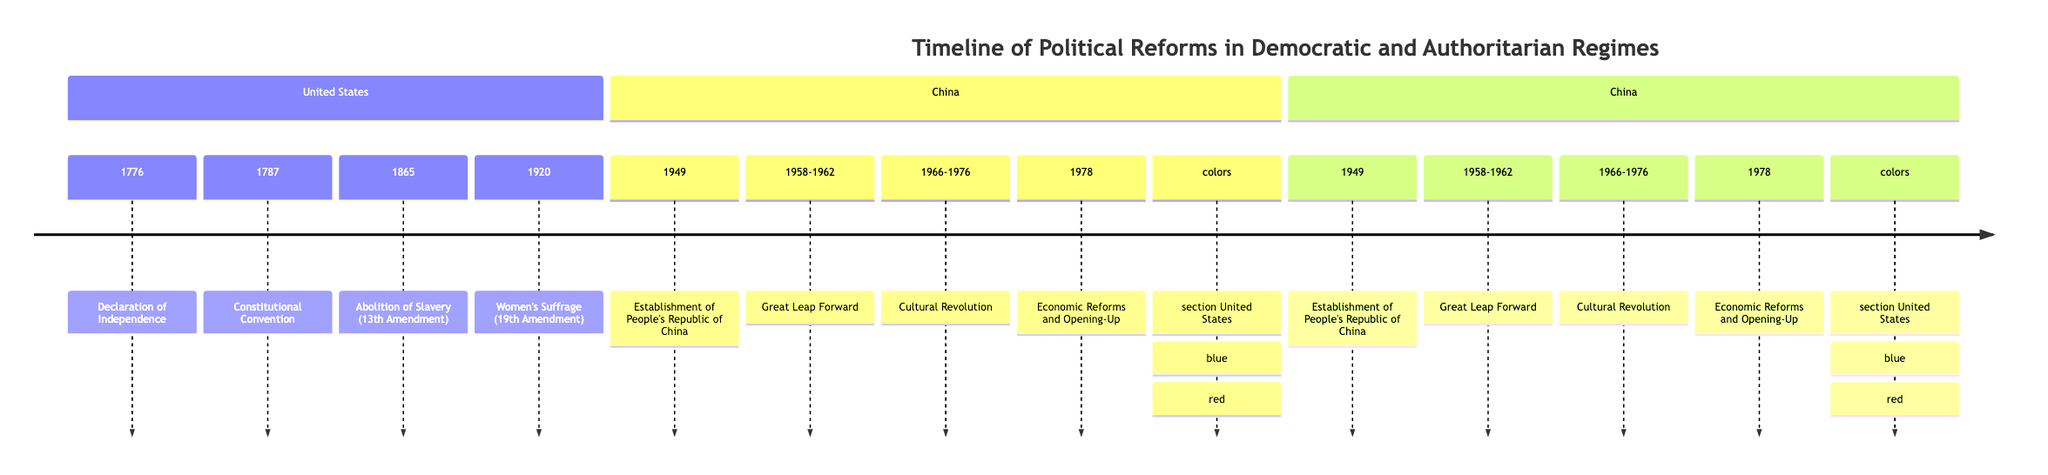What year was the Declaration of Independence established in the United States? The timeline indicates that the Declaration of Independence was established in 1776. This is a direct reference under the section titled "United States."
Answer: 1776 What reform occurred in the United States in 1920? The timeline shows that in 1920, the Women's Suffrage movement was recognized with the 19th Amendment. This can be found under the "United States" section of the diagram.
Answer: Women's Suffrage (19th Amendment) How many major political reforms are shown for China? By counting the events listed under the section labeled "China," we find four major reforms: the establishment of the People's Republic of China, the Great Leap Forward, the Cultural Revolution, and Economic Reforms and Opening-Up. Thus, there are four events in total.
Answer: 4 When did the Great Leap Forward occur in China? The timeline specifies that the Great Leap Forward started in 1958 and ended in 1962. We look for the specific range stated in the "China" section, which identifies the corresponding years.
Answer: 1958-1962 Which event marked the end of slavery in the United States? According to the diagram, the abolition of slavery is indicated as occurring with the 13th Amendment in 1865 under the "United States" section, marking the event that ended slavery.
Answer: Abolition of Slavery (13th Amendment) What was the first major political reform listed for China? The timeline lists the first major political reform for China as the establishment of the People's Republic of China in 1949, which is the earliest event shown in the "China" section of the diagram.
Answer: Establishment of People's Republic of China In what year did the Cultural Revolution occur? The timeline indicates that the Cultural Revolution spanned from 1966 to 1976. To answer specifically, we reference the entry for this event under the "China" section.
Answer: 1966-1976 Which country first recognized women's suffrage according to the timeline? The diagram indicates that women's suffrage was recognized in the United States in 1920. Thus, by referring to the events listed in the "United States" section, we identify the timing of this reform.
Answer: United States What colors represent the United States and China in the diagram? Looking at the color scheme outlined in the diagram, the United States is represented in blue, while China is represented in red. This is explicitly stated in the color section of the diagram.
Answer: Blue, Red 